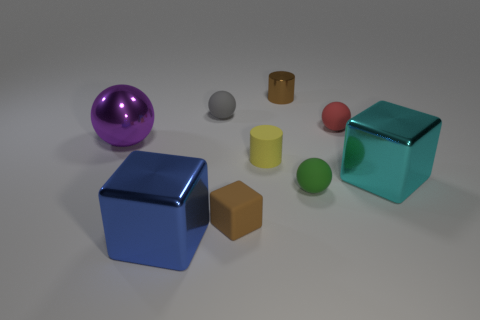What number of other things are the same shape as the green thing?
Make the answer very short. 3. Are there any big objects made of the same material as the big sphere?
Your response must be concise. Yes. Are the big thing right of the small gray thing and the big thing that is in front of the green thing made of the same material?
Make the answer very short. Yes. How many large cyan cubes are there?
Make the answer very short. 1. The tiny brown thing behind the large purple sphere has what shape?
Your response must be concise. Cylinder. How many other objects are there of the same size as the yellow rubber thing?
Ensure brevity in your answer.  5. There is a big metal object that is on the right side of the tiny red object; is it the same shape as the brown object that is in front of the red sphere?
Offer a very short reply. Yes. There is a tiny metallic cylinder; what number of matte objects are to the left of it?
Keep it short and to the point. 3. What color is the sphere on the left side of the tiny gray object?
Provide a short and direct response. Purple. What is the color of the other matte object that is the same shape as the large cyan thing?
Provide a short and direct response. Brown. 